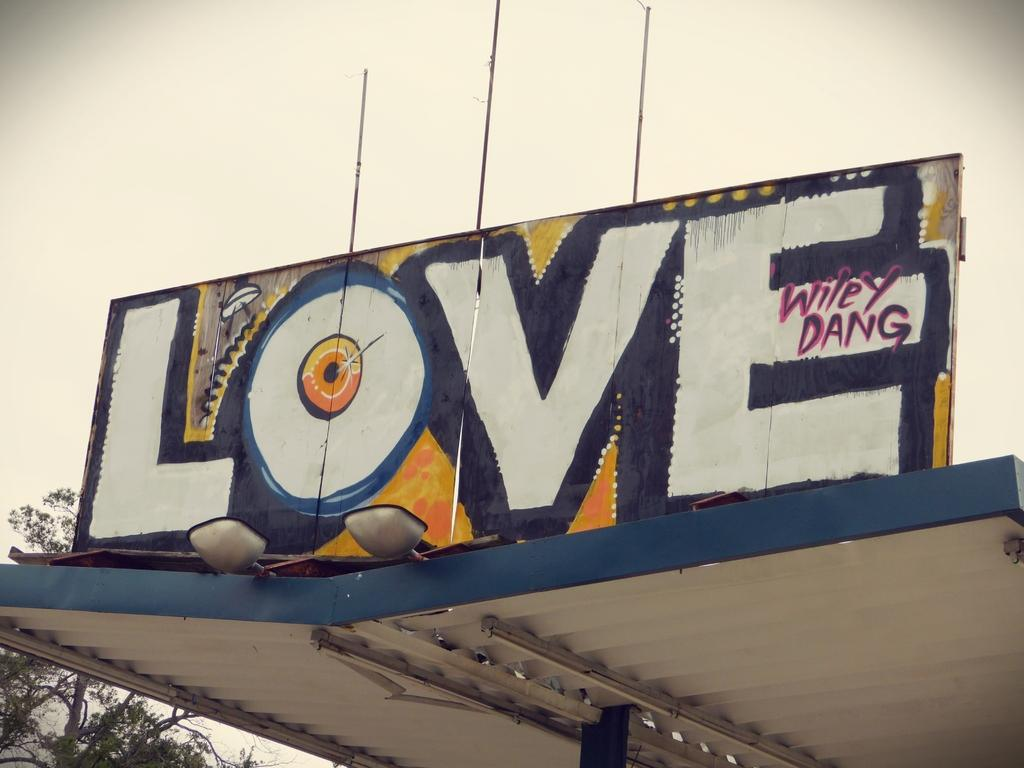<image>
Present a compact description of the photo's key features. A large sign says love and is signed by Wiley Dang. 